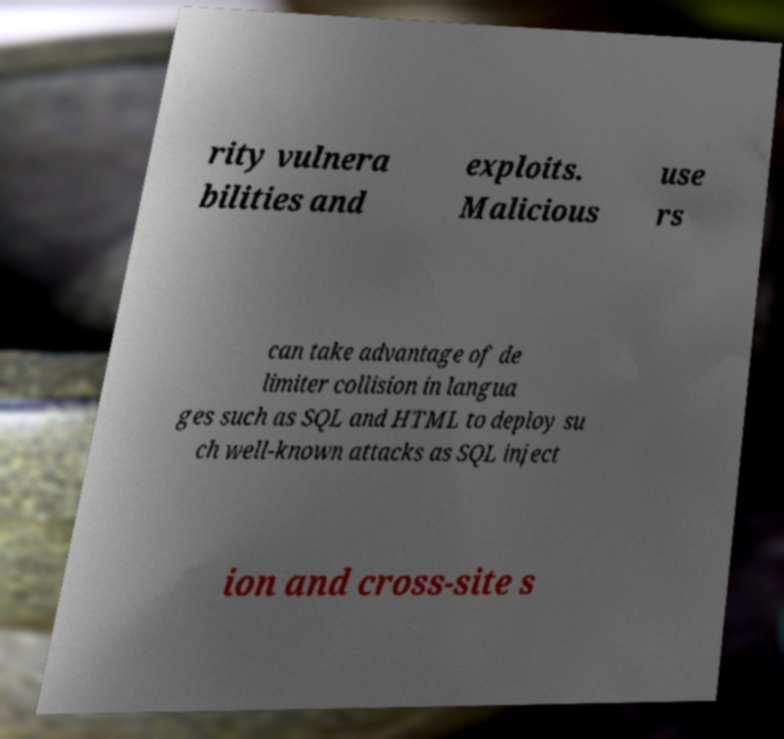I need the written content from this picture converted into text. Can you do that? rity vulnera bilities and exploits. Malicious use rs can take advantage of de limiter collision in langua ges such as SQL and HTML to deploy su ch well-known attacks as SQL inject ion and cross-site s 